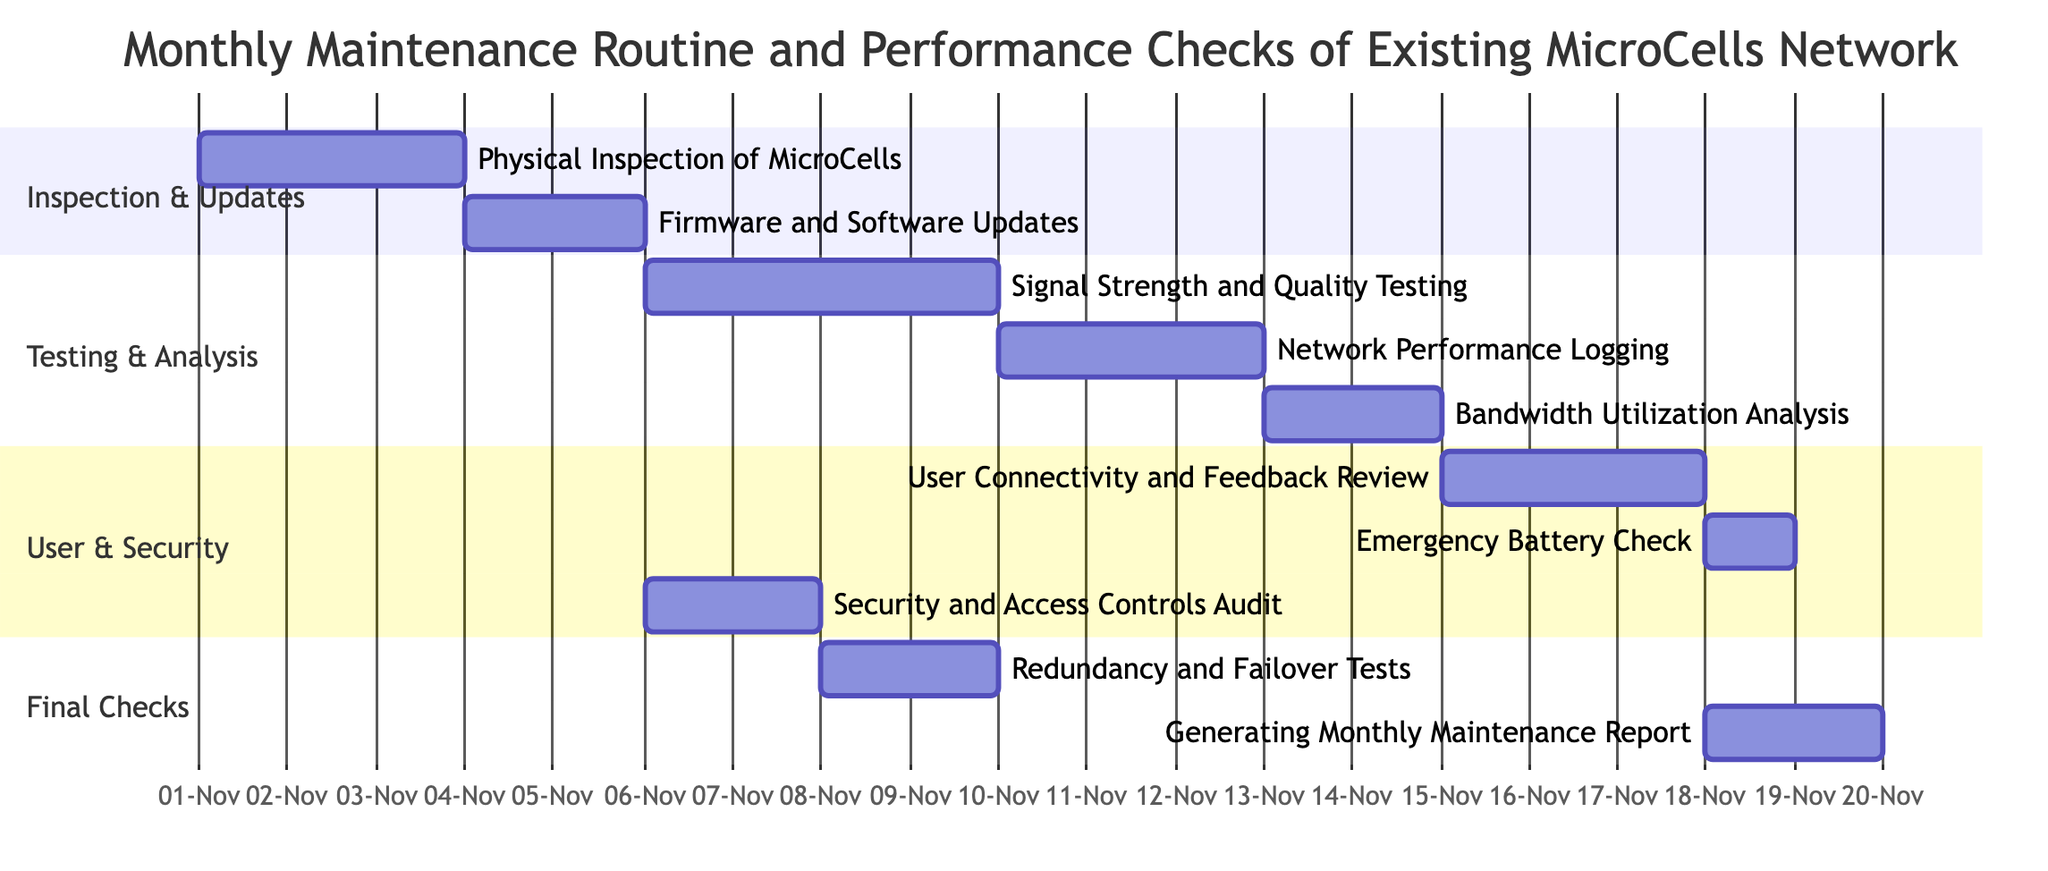What is the duration of the "Signal Strength and Quality Testing"? The task "Signal Strength and Quality Testing" has a duration of 4 days as indicated in the Gantt chart.
Answer: 4 days Which task is dependent on "Firmware and Software Updates"? The tasks that depend on "Firmware and Software Updates" are "Signal Strength and Quality Testing" and "Security and Access Controls Audit". Therefore, "Signal Strength and Quality Testing" is one of the tasks dependent on it.
Answer: Signal Strength and Quality Testing How many tasks are scheduled to start on November 18, 2023? There are two tasks that are scheduled to start on November 18, 2023. One is "Emergency Battery Check" and the other task "User Connectivity and Feedback Review" starts before it, ending on this date as well.
Answer: 1 What is the relationship between "Redundancy and Failover Tests" and "User Connectivity and Feedback Review"? "Redundancy and Failover Tests" is dependent on "Security and Access Controls Audit" which in turn is dependent on "Firmware and Software Updates". The "User Connectivity and Feedback Review" is an independent task that feeds into generating the report. Therefore, their relationship is indirect and based on sequential task dependencies.
Answer: Indirect What is the total duration of tasks that require user feedback review? The total duration of "User Connectivity and Feedback Review" is 3 days, and it is followed by the report generation task for another 2 days. Therefore, the total duration of tasks requiring feedback review is 5 days.
Answer: 5 days Which section contains the "Firmware and Software Updates"? The task "Firmware and Software Updates" is located in the section "Inspection & Updates". This can be identified by its categorization and structure within the Gantt chart.
Answer: Inspection & Updates What are the start dates of the "Generating Monthly Maintenance Report"? The task "Generating Monthly Maintenance Report" starts on November 23, 2023. This is clearly indicated under the 'Final Checks' section.
Answer: November 23, 2023 How many total tasks are there in the Gantt chart? There are a total of 10 tasks listed in the Gantt chart, covering various aspects of the monthly maintenance routine and performance checks for the MicroCell systems.
Answer: 10 